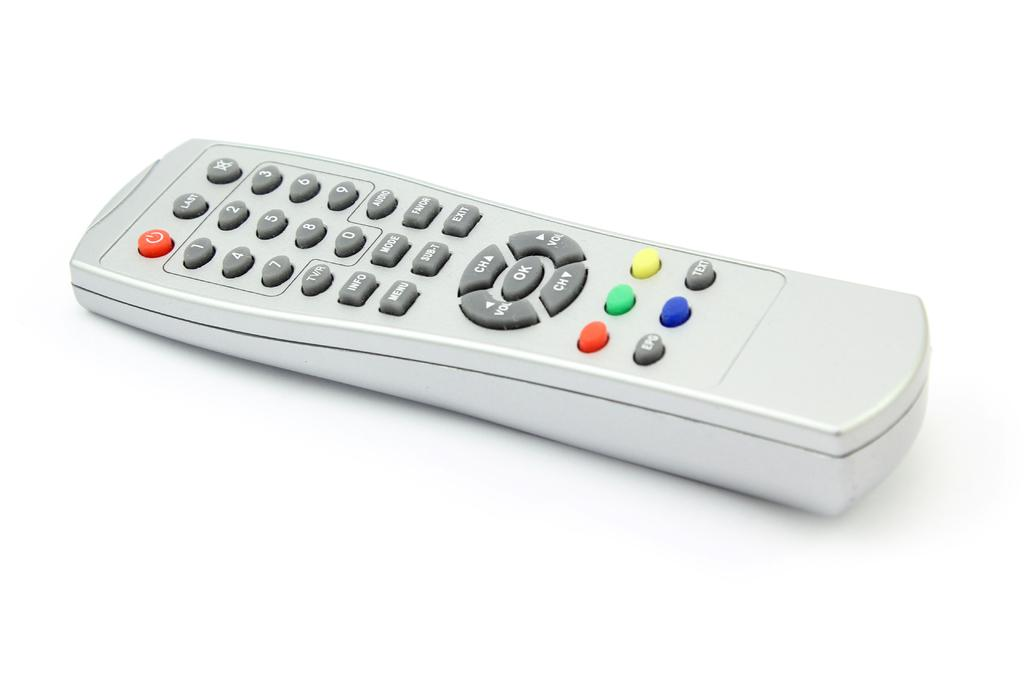Provide a one-sentence caption for the provided image. a remote with the word ok on it. 